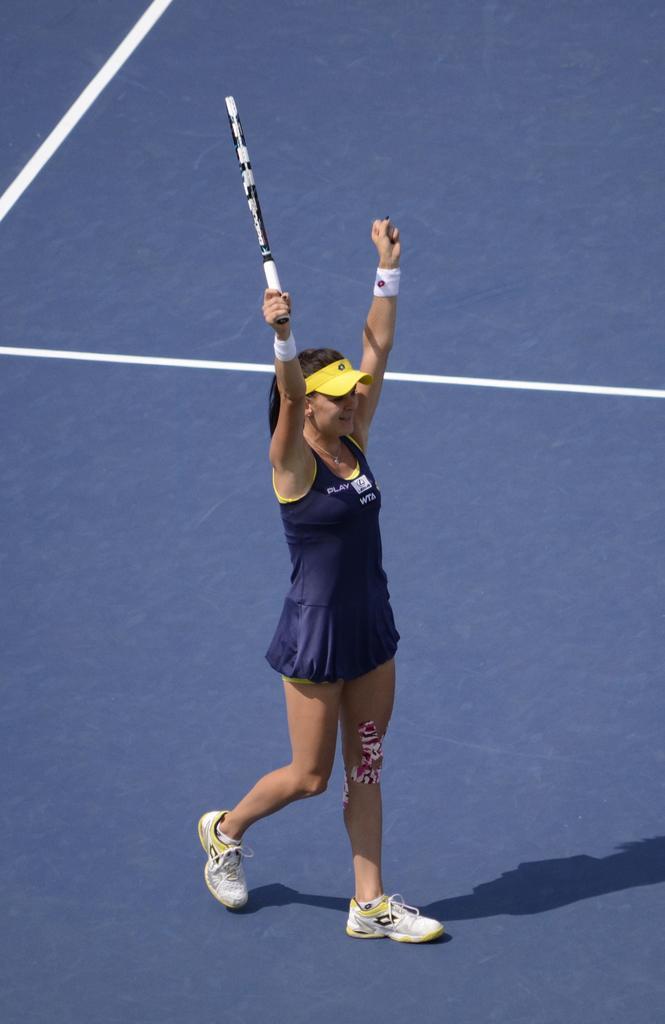How would you summarize this image in a sentence or two? In this image a woman is walking and raising her hands up, wearing yellow colour cap and blue colour dress and wearing shoes is holding a bat in her hand. 